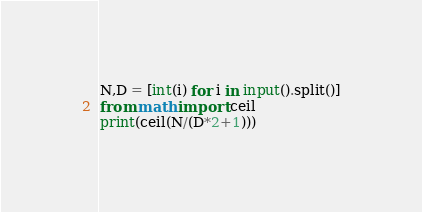<code> <loc_0><loc_0><loc_500><loc_500><_Python_>N,D = [int(i) for i in input().split()]
from math import ceil
print(ceil(N/(D*2+1)))</code> 